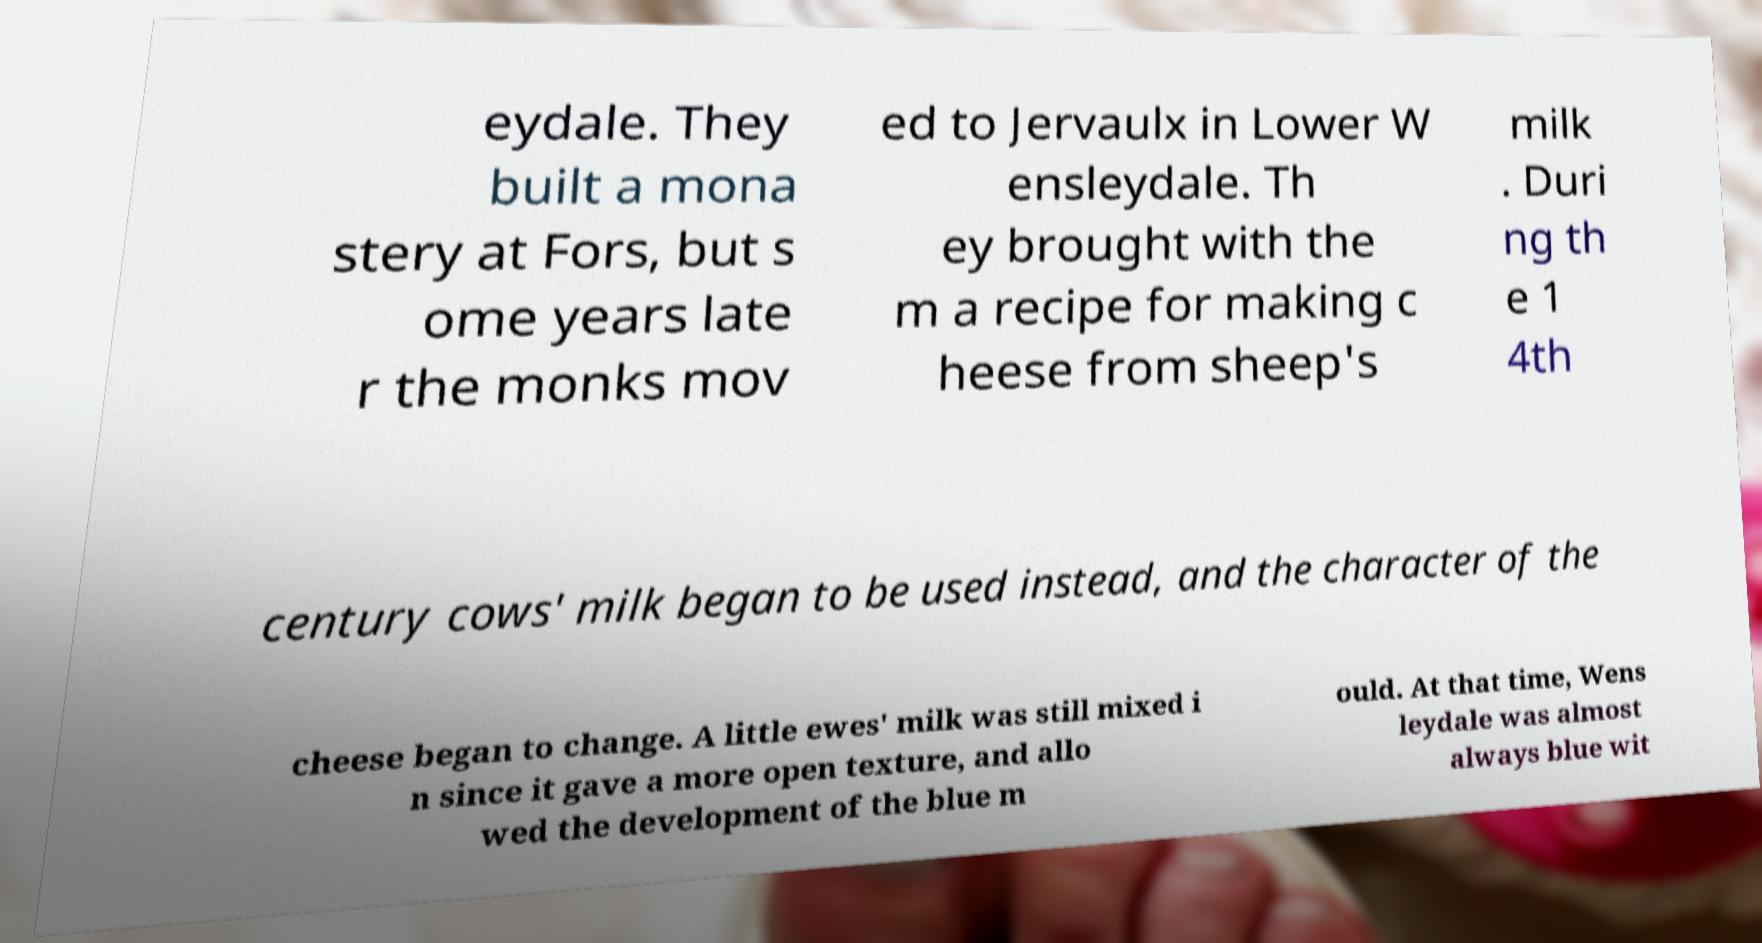Can you accurately transcribe the text from the provided image for me? eydale. They built a mona stery at Fors, but s ome years late r the monks mov ed to Jervaulx in Lower W ensleydale. Th ey brought with the m a recipe for making c heese from sheep's milk . Duri ng th e 1 4th century cows' milk began to be used instead, and the character of the cheese began to change. A little ewes' milk was still mixed i n since it gave a more open texture, and allo wed the development of the blue m ould. At that time, Wens leydale was almost always blue wit 